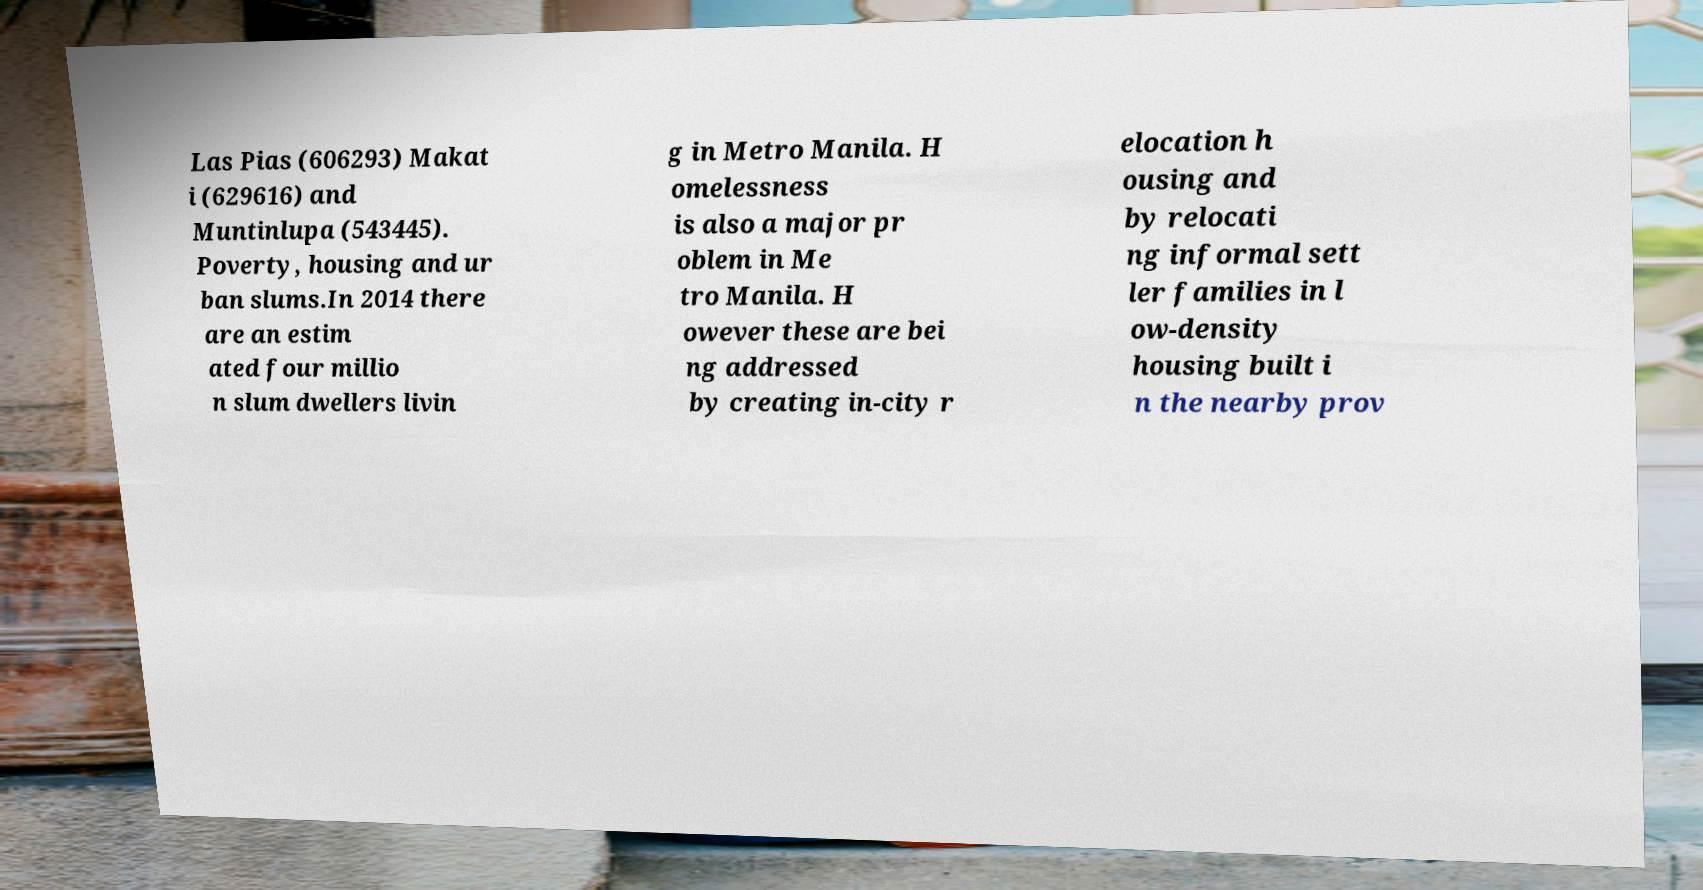Can you accurately transcribe the text from the provided image for me? Las Pias (606293) Makat i (629616) and Muntinlupa (543445). Poverty, housing and ur ban slums.In 2014 there are an estim ated four millio n slum dwellers livin g in Metro Manila. H omelessness is also a major pr oblem in Me tro Manila. H owever these are bei ng addressed by creating in-city r elocation h ousing and by relocati ng informal sett ler families in l ow-density housing built i n the nearby prov 